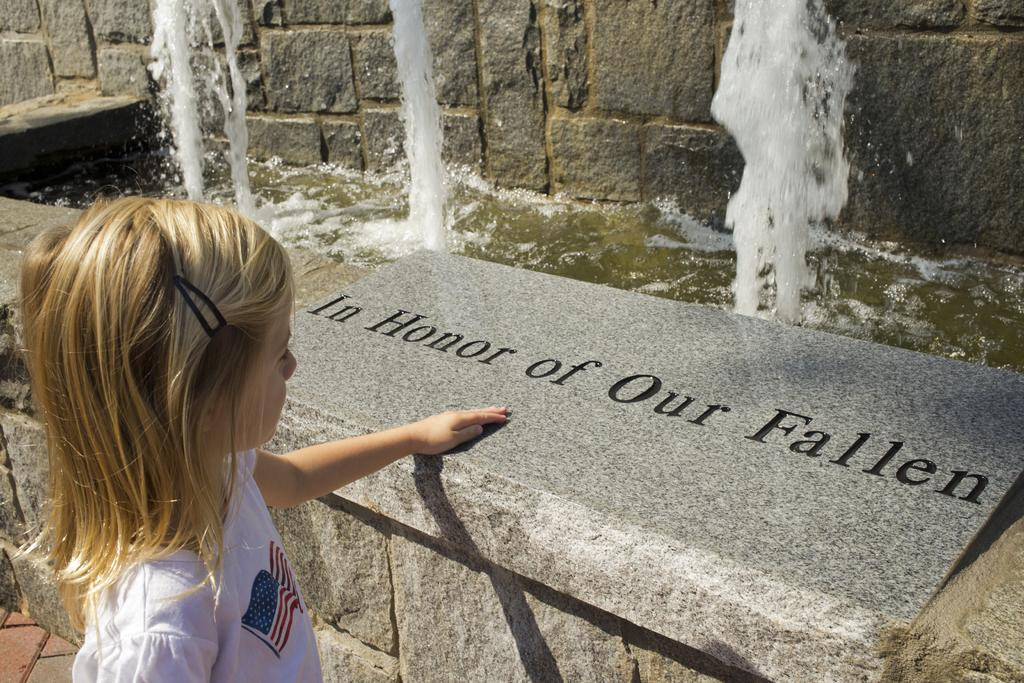What is the main subject of the image? There is a child in the image. What is located near the child? There is a stone wall near the child. What is written or depicted on the stone wall? There is text on the stone wall. What can be seen in the background of the image? There is another stone wall in the background and water visible in the image. How many screws can be seen holding the child's toy together in the image? There is no toy or screws present in the image. 